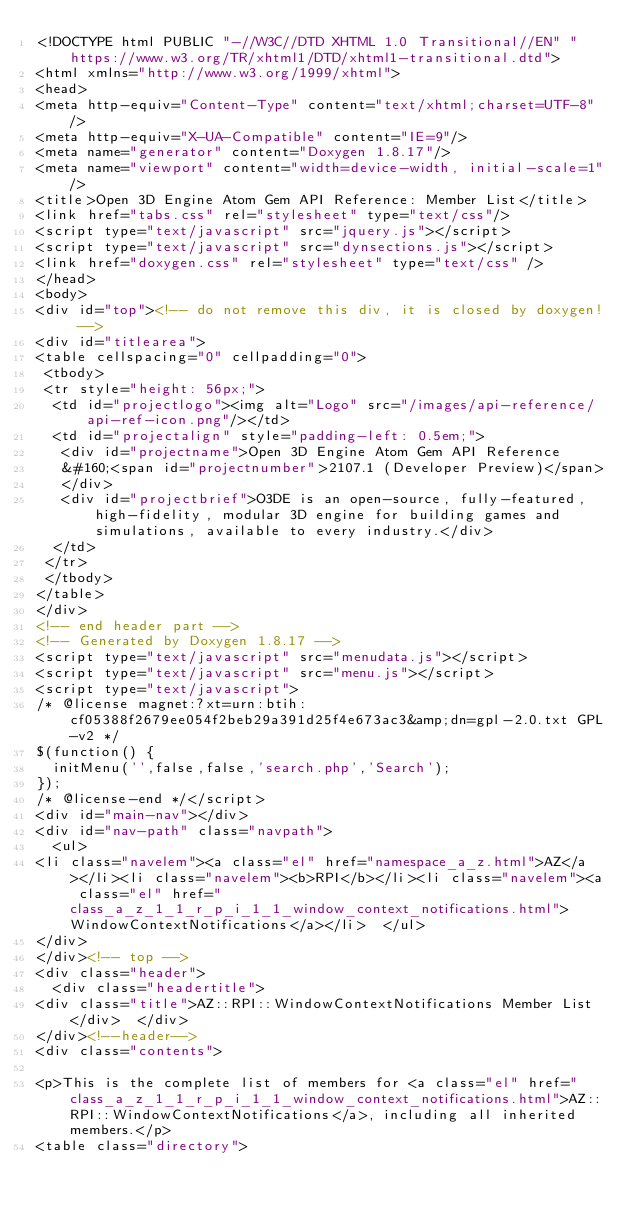Convert code to text. <code><loc_0><loc_0><loc_500><loc_500><_HTML_><!DOCTYPE html PUBLIC "-//W3C//DTD XHTML 1.0 Transitional//EN" "https://www.w3.org/TR/xhtml1/DTD/xhtml1-transitional.dtd">
<html xmlns="http://www.w3.org/1999/xhtml">
<head>
<meta http-equiv="Content-Type" content="text/xhtml;charset=UTF-8"/>
<meta http-equiv="X-UA-Compatible" content="IE=9"/>
<meta name="generator" content="Doxygen 1.8.17"/>
<meta name="viewport" content="width=device-width, initial-scale=1"/>
<title>Open 3D Engine Atom Gem API Reference: Member List</title>
<link href="tabs.css" rel="stylesheet" type="text/css"/>
<script type="text/javascript" src="jquery.js"></script>
<script type="text/javascript" src="dynsections.js"></script>
<link href="doxygen.css" rel="stylesheet" type="text/css" />
</head>
<body>
<div id="top"><!-- do not remove this div, it is closed by doxygen! -->
<div id="titlearea">
<table cellspacing="0" cellpadding="0">
 <tbody>
 <tr style="height: 56px;">
  <td id="projectlogo"><img alt="Logo" src="/images/api-reference/api-ref-icon.png"/></td>
  <td id="projectalign" style="padding-left: 0.5em;">
   <div id="projectname">Open 3D Engine Atom Gem API Reference
   &#160;<span id="projectnumber">2107.1 (Developer Preview)</span>
   </div>
   <div id="projectbrief">O3DE is an open-source, fully-featured, high-fidelity, modular 3D engine for building games and simulations, available to every industry.</div>
  </td>
 </tr>
 </tbody>
</table>
</div>
<!-- end header part -->
<!-- Generated by Doxygen 1.8.17 -->
<script type="text/javascript" src="menudata.js"></script>
<script type="text/javascript" src="menu.js"></script>
<script type="text/javascript">
/* @license magnet:?xt=urn:btih:cf05388f2679ee054f2beb29a391d25f4e673ac3&amp;dn=gpl-2.0.txt GPL-v2 */
$(function() {
  initMenu('',false,false,'search.php','Search');
});
/* @license-end */</script>
<div id="main-nav"></div>
<div id="nav-path" class="navpath">
  <ul>
<li class="navelem"><a class="el" href="namespace_a_z.html">AZ</a></li><li class="navelem"><b>RPI</b></li><li class="navelem"><a class="el" href="class_a_z_1_1_r_p_i_1_1_window_context_notifications.html">WindowContextNotifications</a></li>  </ul>
</div>
</div><!-- top -->
<div class="header">
  <div class="headertitle">
<div class="title">AZ::RPI::WindowContextNotifications Member List</div>  </div>
</div><!--header-->
<div class="contents">

<p>This is the complete list of members for <a class="el" href="class_a_z_1_1_r_p_i_1_1_window_context_notifications.html">AZ::RPI::WindowContextNotifications</a>, including all inherited members.</p>
<table class="directory"></code> 